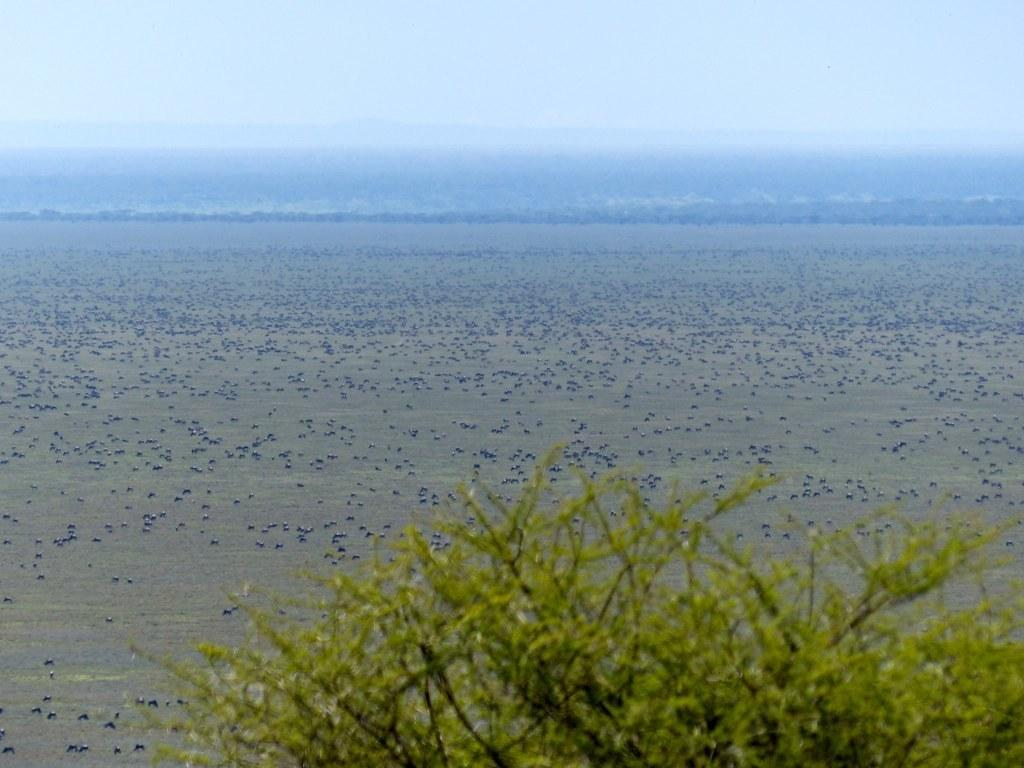What type of living organisms can be seen in the image? Plants and animals are visible in the image. Where are the animals located in the image? The animals are on a path in the image. What can be seen in the background of the image? The sky is visible in the background of the image. What type of account is being discussed in the image? There is no account being discussed in the image; it features plants and animals on a path with the sky visible in the background. 